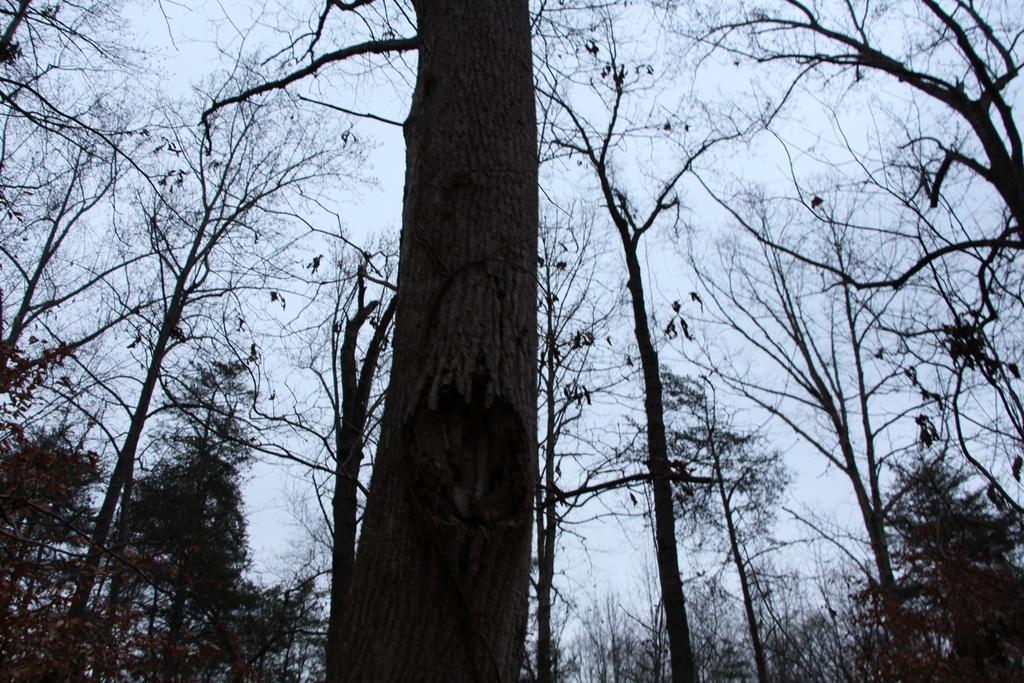Could you give a brief overview of what you see in this image? In this image, we can see there are trees on the ground. And there are clouds in the sky. 